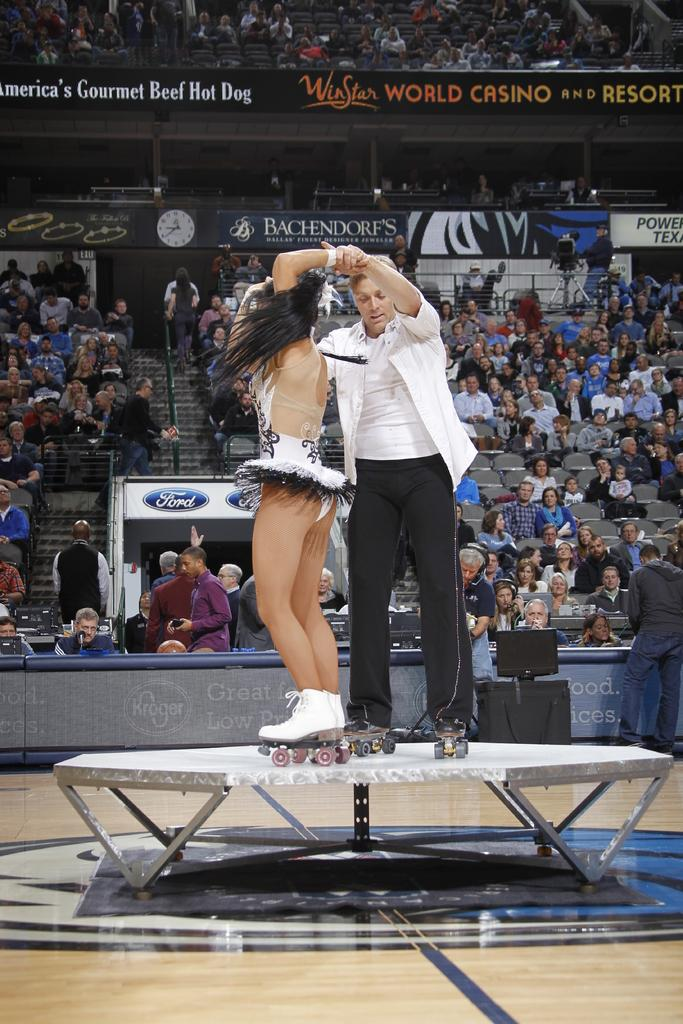What are the two people in the image doing? The two people in the image are dancing. Where are the people dancing? They are dancing on a table. What can be seen in the background of the image? There are people sitting in the background of the image. How are the people sitting arranged? The people sitting are on chairs. What type of hook can be seen hanging from the ceiling in the image? There is no hook visible in the image; it features two people dancing on a table and people sitting in the background. What kind of lace is draped over the chairs in the image? There is no lace present in the image; the chairs are simply occupied by people sitting. 